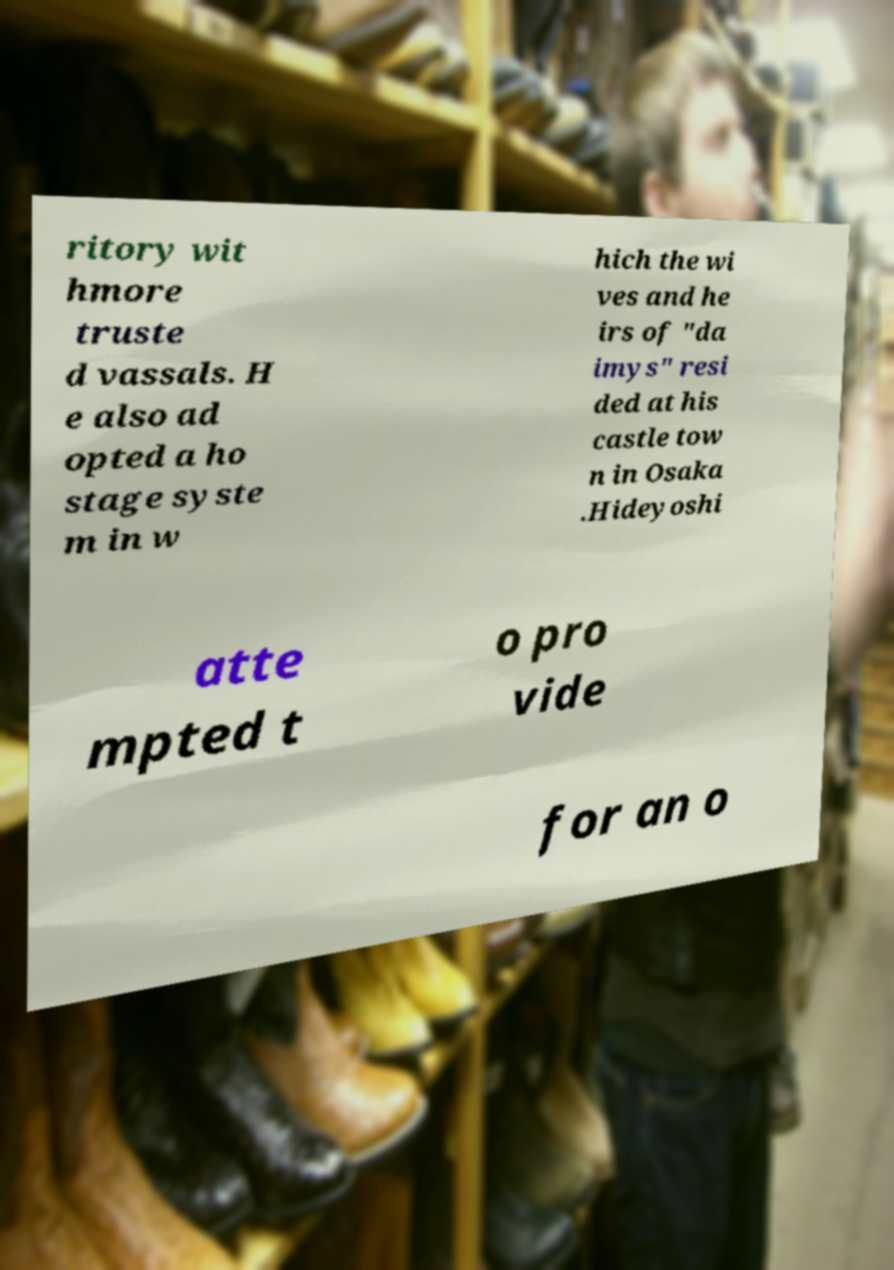Can you accurately transcribe the text from the provided image for me? ritory wit hmore truste d vassals. H e also ad opted a ho stage syste m in w hich the wi ves and he irs of "da imys" resi ded at his castle tow n in Osaka .Hideyoshi atte mpted t o pro vide for an o 